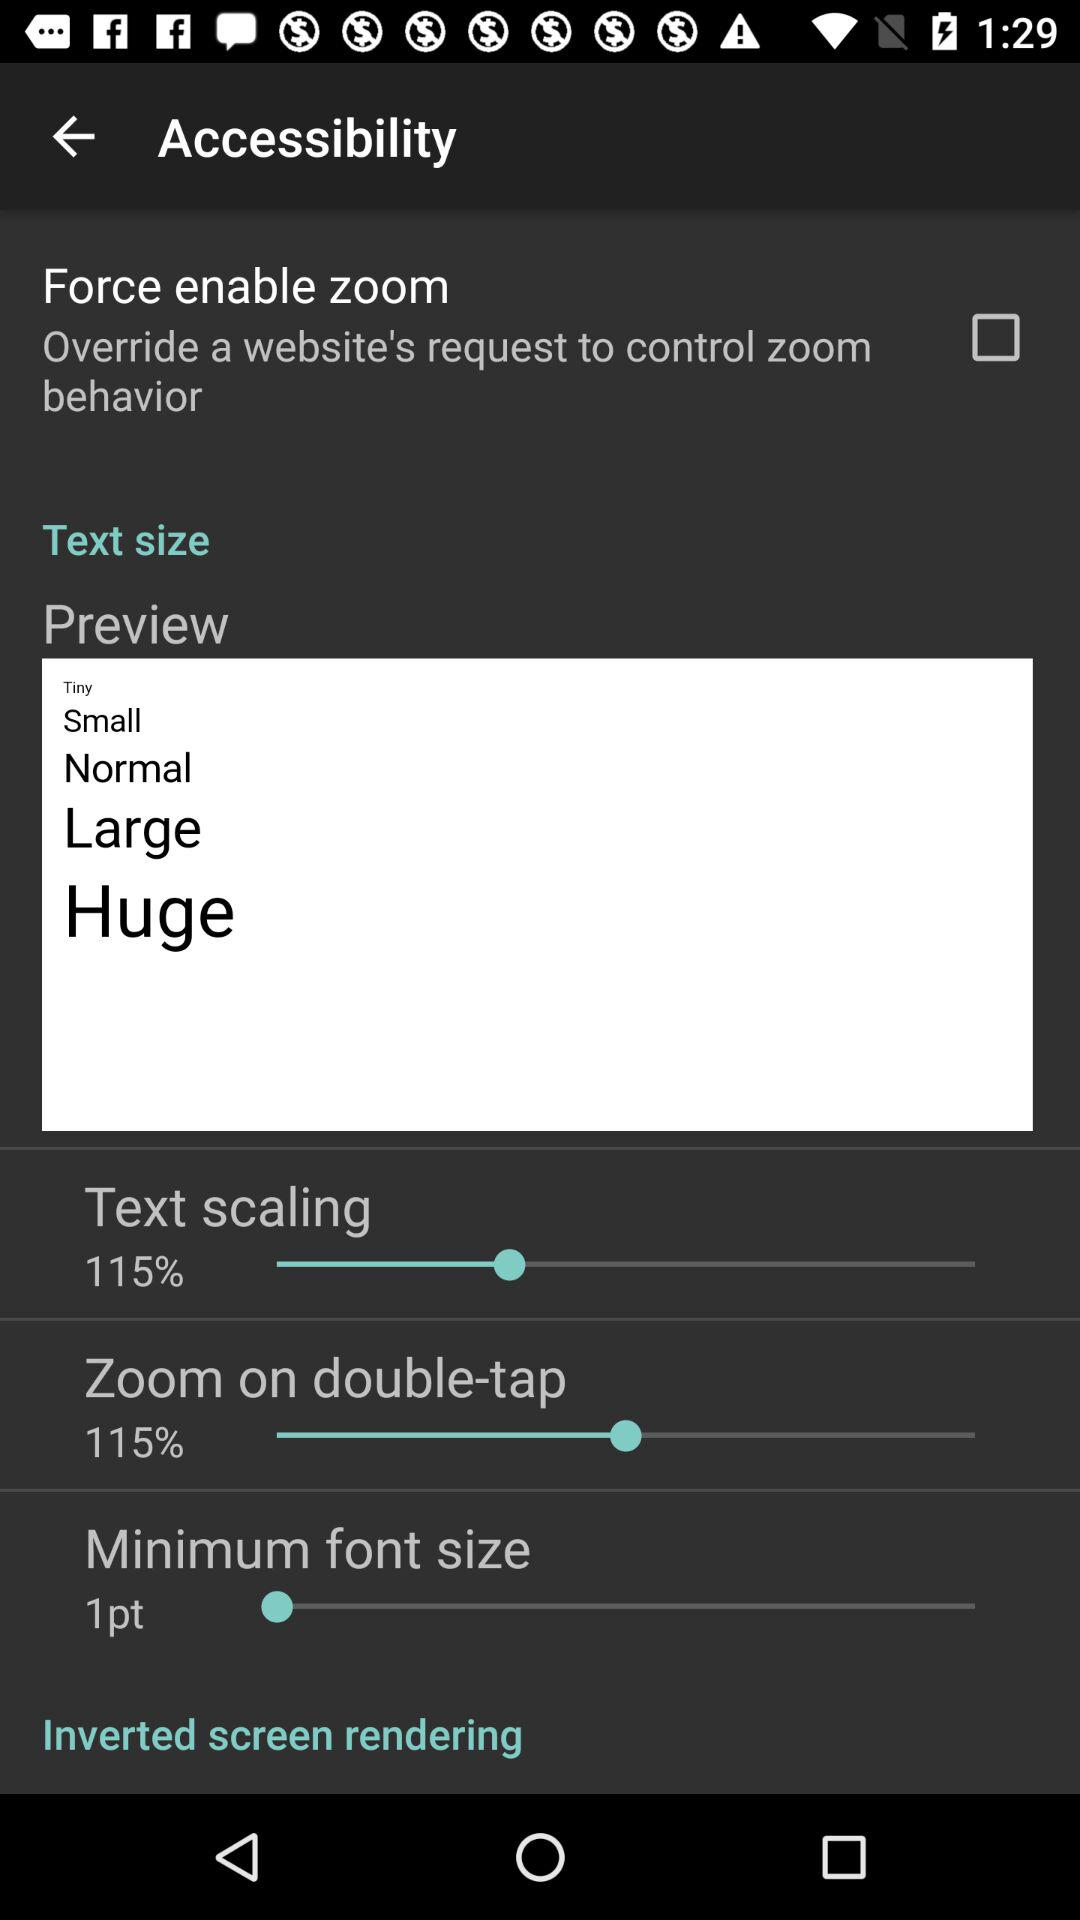How many text size options are there?
Answer the question using a single word or phrase. 5 